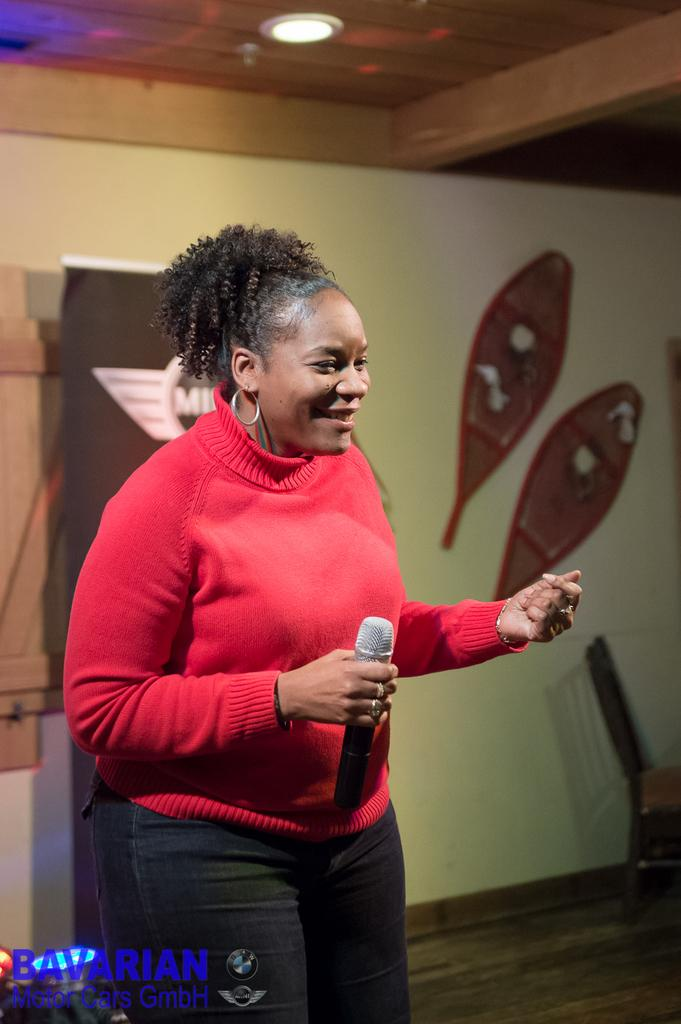Who is the main subject in the image? There is a woman in the image. What is the woman doing in the image? The woman is speaking in the image. What object is the woman holding in her hand? The woman is holding a microphone in her hand. What is the size of the floor in the image? There is no information about the size of the floor in the image, as the focus is on the woman and her actions. 